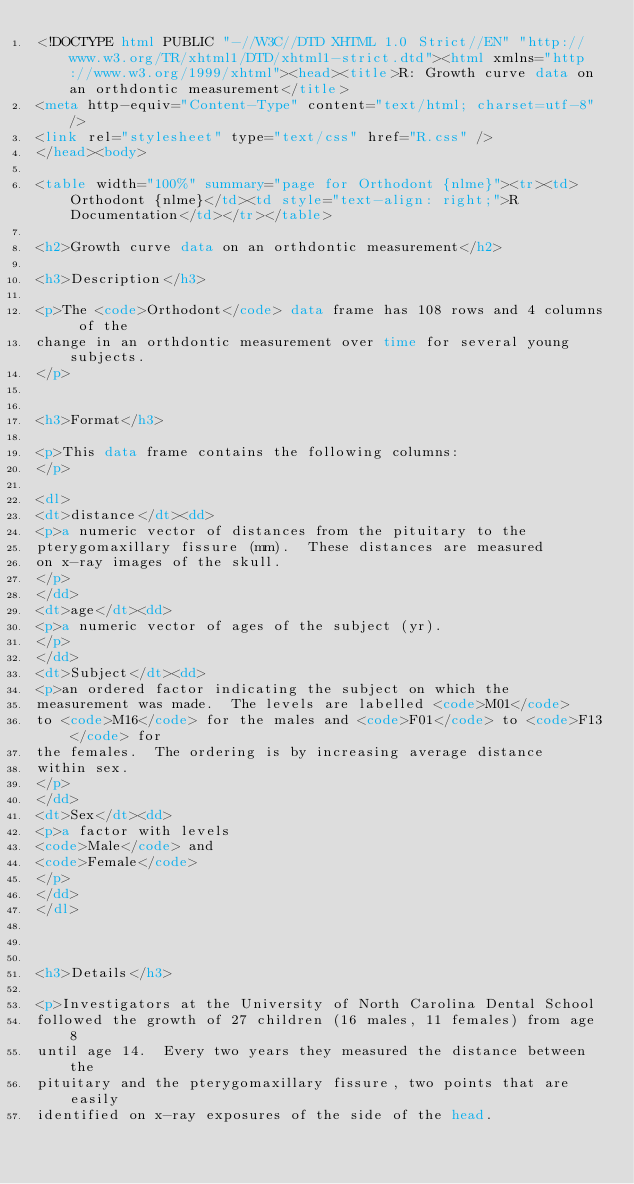<code> <loc_0><loc_0><loc_500><loc_500><_HTML_><!DOCTYPE html PUBLIC "-//W3C//DTD XHTML 1.0 Strict//EN" "http://www.w3.org/TR/xhtml1/DTD/xhtml1-strict.dtd"><html xmlns="http://www.w3.org/1999/xhtml"><head><title>R: Growth curve data on an orthdontic measurement</title>
<meta http-equiv="Content-Type" content="text/html; charset=utf-8" />
<link rel="stylesheet" type="text/css" href="R.css" />
</head><body>

<table width="100%" summary="page for Orthodont {nlme}"><tr><td>Orthodont {nlme}</td><td style="text-align: right;">R Documentation</td></tr></table>

<h2>Growth curve data on an orthdontic measurement</h2>

<h3>Description</h3>

<p>The <code>Orthodont</code> data frame has 108 rows and 4 columns of the
change in an orthdontic measurement over time for several young subjects.
</p>


<h3>Format</h3>

<p>This data frame contains the following columns:
</p>

<dl>
<dt>distance</dt><dd>
<p>a numeric vector of distances from the pituitary to the
pterygomaxillary fissure (mm).  These distances are measured
on x-ray images of the skull.
</p>
</dd>
<dt>age</dt><dd>
<p>a numeric vector of ages of the subject (yr).
</p>
</dd>
<dt>Subject</dt><dd>
<p>an ordered factor indicating the subject on which the
measurement was made.  The levels are labelled <code>M01</code>
to <code>M16</code> for the males and <code>F01</code> to <code>F13</code> for
the females.  The ordering is by increasing average distance
within sex.
</p>
</dd>
<dt>Sex</dt><dd>
<p>a factor with levels
<code>Male</code> and
<code>Female</code> 
</p>
</dd>
</dl>



<h3>Details</h3>

<p>Investigators at the University of North Carolina Dental School
followed the growth of 27 children (16 males, 11 females) from age 8
until age 14.  Every two years they measured the distance between the
pituitary and the pterygomaxillary fissure, two points that are easily
identified on x-ray exposures of the side of the head.</code> 